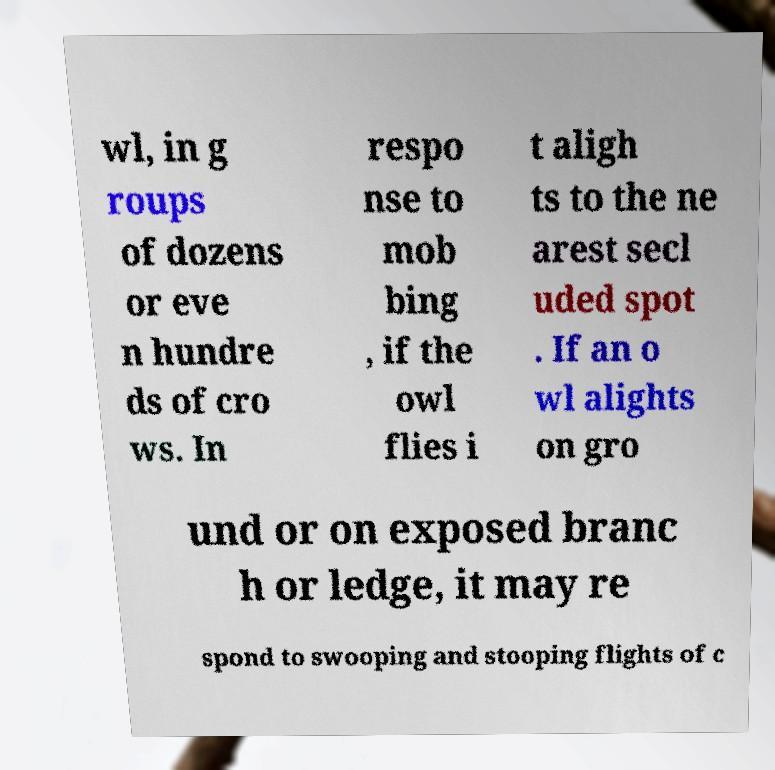Can you read and provide the text displayed in the image?This photo seems to have some interesting text. Can you extract and type it out for me? wl, in g roups of dozens or eve n hundre ds of cro ws. In respo nse to mob bing , if the owl flies i t aligh ts to the ne arest secl uded spot . If an o wl alights on gro und or on exposed branc h or ledge, it may re spond to swooping and stooping flights of c 